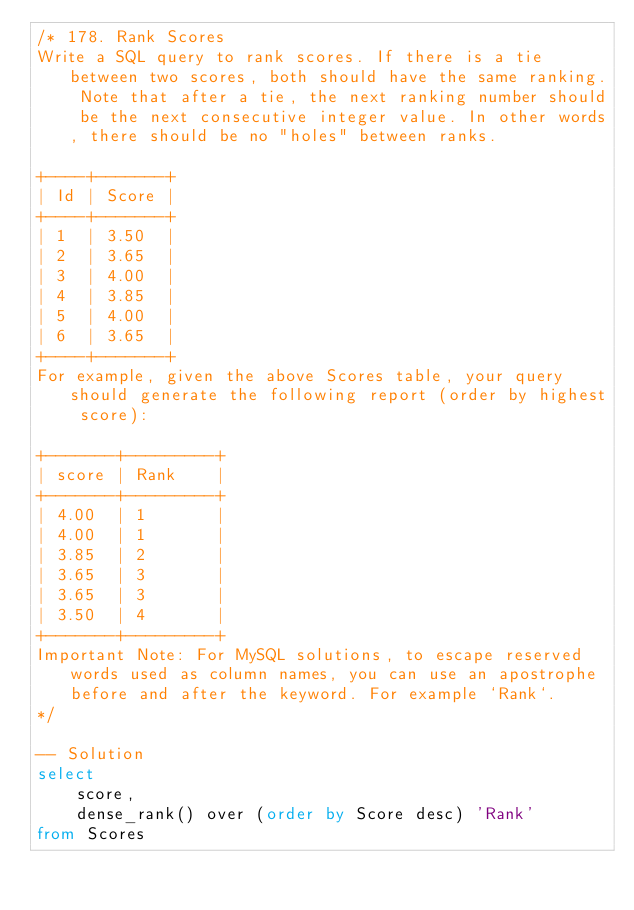<code> <loc_0><loc_0><loc_500><loc_500><_SQL_>/* 178. Rank Scores
Write a SQL query to rank scores. If there is a tie between two scores, both should have the same ranking. Note that after a tie, the next ranking number should be the next consecutive integer value. In other words, there should be no "holes" between ranks.

+----+-------+
| Id | Score |
+----+-------+
| 1  | 3.50  |
| 2  | 3.65  |
| 3  | 4.00  |
| 4  | 3.85  |
| 5  | 4.00  |
| 6  | 3.65  |
+----+-------+
For example, given the above Scores table, your query should generate the following report (order by highest score):

+-------+---------+
| score | Rank    |
+-------+---------+
| 4.00  | 1       |
| 4.00  | 1       |
| 3.85  | 2       |
| 3.65  | 3       |
| 3.65  | 3       |
| 3.50  | 4       |
+-------+---------+
Important Note: For MySQL solutions, to escape reserved words used as column names, you can use an apostrophe before and after the keyword. For example `Rank`.
*/

-- Solution 
select 
    score, 
    dense_rank() over (order by Score desc) 'Rank'
from Scores</code> 